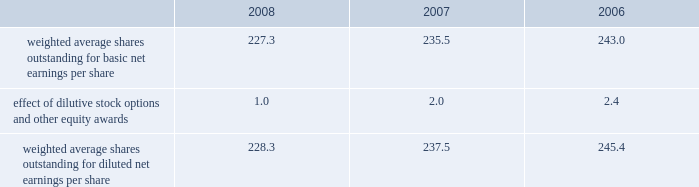Reasonably possible that such matters will be resolved in the next twelve months , but we do not anticipate that the resolution of these matters would result in any material impact on our results of operations or financial position .
Foreign jurisdictions have statutes of limitations generally ranging from 3 to 5 years .
Years still open to examination by foreign tax authorities in major jurisdictions include australia ( 2003 onward ) , canada ( 2002 onward ) , france ( 2006 onward ) , germany ( 2005 onward ) , italy ( 2005 onward ) , japan ( 2002 onward ) , puerto rico ( 2005 onward ) , singapore ( 2003 onward ) , switzerland ( 2006 onward ) and the united kingdom ( 2006 onward ) .
Our tax returns are currently under examination in various foreign jurisdictions .
The most significant foreign tax jurisdiction under examination is the united kingdom .
It is reasonably possible that such audits will be resolved in the next twelve months , but we do not anticipate that the resolution of these audits would result in any material impact on our results of operations or financial position .
13 .
Capital stock and earnings per share we are authorized to issue 250 million shares of preferred stock , none of which were issued or outstanding as of december 31 , 2008 .
The numerator for both basic and diluted earnings per share is net earnings available to common stockholders .
The denominator for basic earnings per share is the weighted average number of common shares outstanding during the period .
The denominator for diluted earnings per share is weighted average shares outstanding adjusted for the effect of dilutive stock options and other equity awards .
The following is a reconciliation of weighted average shares for the basic and diluted share computations for the years ending december 31 ( in millions ) : .
Weighted average shares outstanding for basic net earnings per share 227.3 235.5 243.0 effect of dilutive stock options and other equity awards 1.0 2.0 2.4 weighted average shares outstanding for diluted net earnings per share 228.3 237.5 245.4 for the year ended december 31 , 2008 , an average of 11.2 million options to purchase shares of common stock were not included in the computation of diluted earnings per share as the exercise prices of these options were greater than the average market price of the common stock .
For the years ended december 31 , 2007 and 2006 , an average of 3.1 million and 7.6 million options , respectively , were not included .
During 2008 , we repurchased approximately 10.8 million shares of our common stock at an average price of $ 68.72 per share for a total cash outlay of $ 737.0 million , including commissions .
In april 2008 , we announced that our board of directors authorized a $ 1.25 billion share repurchase program which expires december 31 , 2009 .
Approximately $ 1.13 billion remains authorized under this plan .
14 .
Segment data we design , develop , manufacture and market orthopaedic and dental reconstructive implants , spinal implants , trauma products and related surgical products which include surgical supplies and instruments designed to aid in orthopaedic surgical procedures and post-operation rehabilitation .
We also provide other healthcare-related services .
Revenue related to these services currently represents less than 1 percent of our total net sales .
We manage operations through three major geographic segments 2013 the americas , which is comprised principally of the united states and includes other north , central and south american markets ; europe , which is comprised principally of europe and includes the middle east and africa ; and asia pacific , which is comprised primarily of japan and includes other asian and pacific markets .
This structure is the basis for our reportable segment information discussed below .
Management evaluates operating segment performance based upon segment operating profit exclusive of operating expenses pertaining to global operations and corporate expenses , share-based compensation expense , settlement , certain claims , acquisition , integration and other expenses , inventory step-up , in-process research and development write-offs and intangible asset amortization expense .
Global operations include research , development engineering , medical education , brand management , corporate legal , finance , and human resource functions , and u.s .
And puerto rico-based manufacturing operations and logistics .
Intercompany transactions have been eliminated from segment operating profit .
Management reviews accounts receivable , inventory , property , plant and equipment , goodwill and intangible assets by reportable segment exclusive of u.s and puerto rico-based manufacturing operations and logistics and corporate assets .
Z i m m e r h o l d i n g s , i n c .
2 0 0 8 f o r m 1 0 - k a n n u a l r e p o r t notes to consolidated financial statements ( continued ) %%transmsg*** transmitting job : c48761 pcn : 058000000 ***%%pcmsg|58 |00011|yes|no|02/24/2009 19:25|0|0|page is valid , no graphics -- color : d| .
What was the percentage change in weighted average shares outstanding for diluted net earnings per share from 2007 to 2008? 
Computations: ((228.3 - 237.5) / 237.5)
Answer: -0.03874. 